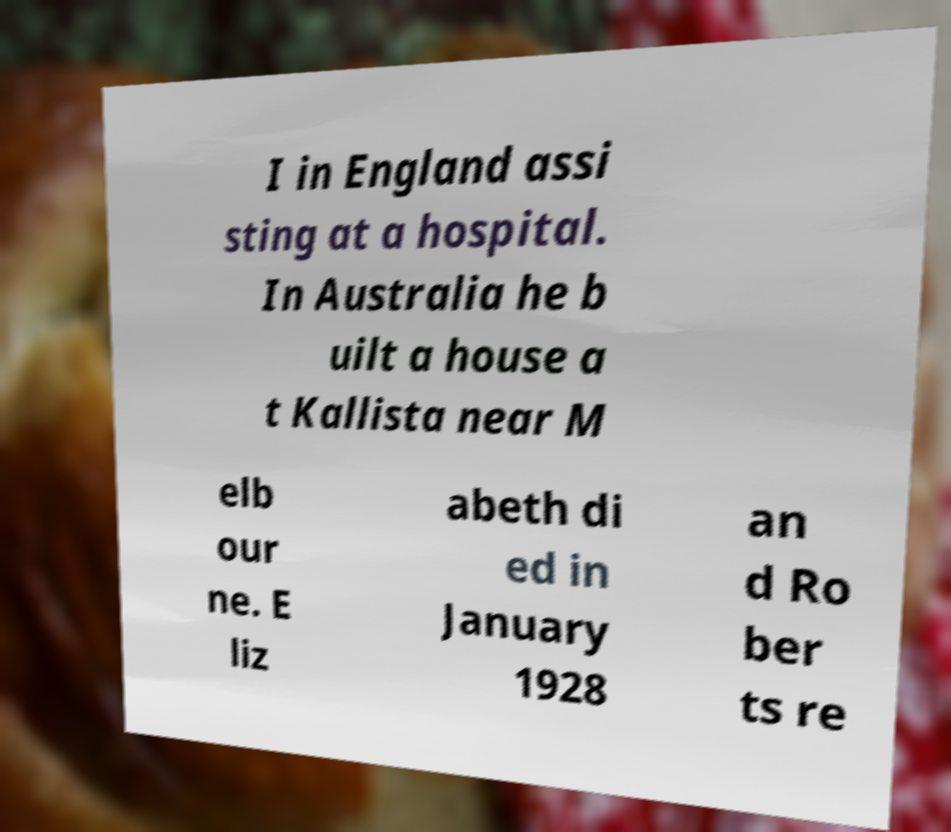Please read and relay the text visible in this image. What does it say? I in England assi sting at a hospital. In Australia he b uilt a house a t Kallista near M elb our ne. E liz abeth di ed in January 1928 an d Ro ber ts re 